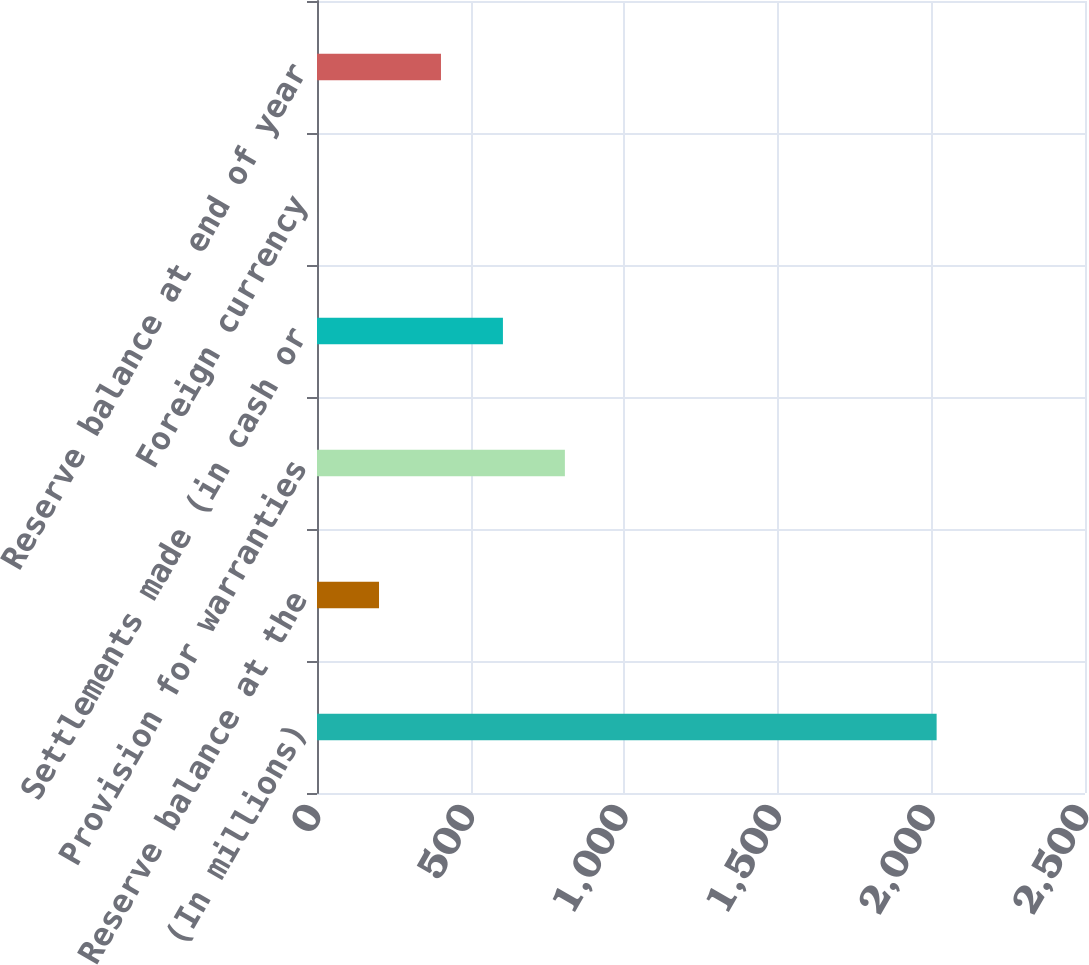Convert chart. <chart><loc_0><loc_0><loc_500><loc_500><bar_chart><fcel>(In millions)<fcel>Reserve balance at the<fcel>Provision for warranties<fcel>Settlements made (in cash or<fcel>Foreign currency<fcel>Reserve balance at end of year<nl><fcel>2017<fcel>201.88<fcel>806.92<fcel>605.24<fcel>0.2<fcel>403.56<nl></chart> 